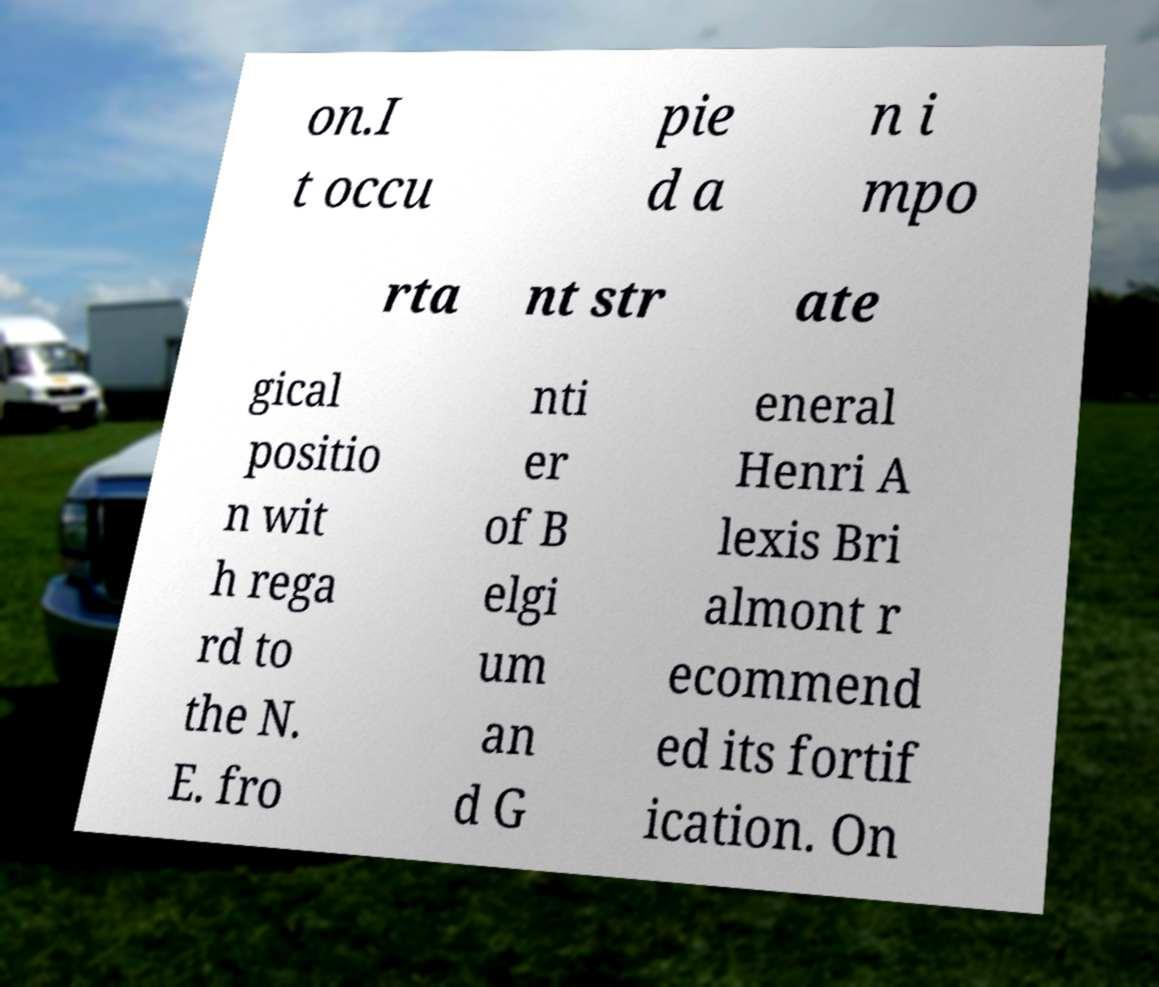Please identify and transcribe the text found in this image. on.I t occu pie d a n i mpo rta nt str ate gical positio n wit h rega rd to the N. E. fro nti er of B elgi um an d G eneral Henri A lexis Bri almont r ecommend ed its fortif ication. On 